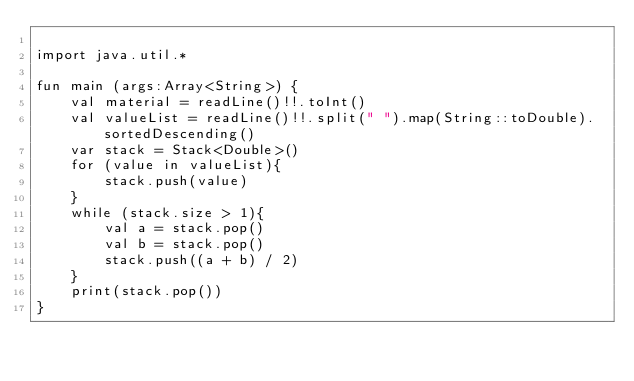<code> <loc_0><loc_0><loc_500><loc_500><_Kotlin_>
import java.util.*

fun main (args:Array<String>) {
    val material = readLine()!!.toInt()
    val valueList = readLine()!!.split(" ").map(String::toDouble).sortedDescending()
    var stack = Stack<Double>()
    for (value in valueList){
        stack.push(value)
    }
    while (stack.size > 1){
        val a = stack.pop()
        val b = stack.pop()
        stack.push((a + b) / 2)
    }
    print(stack.pop())
}</code> 